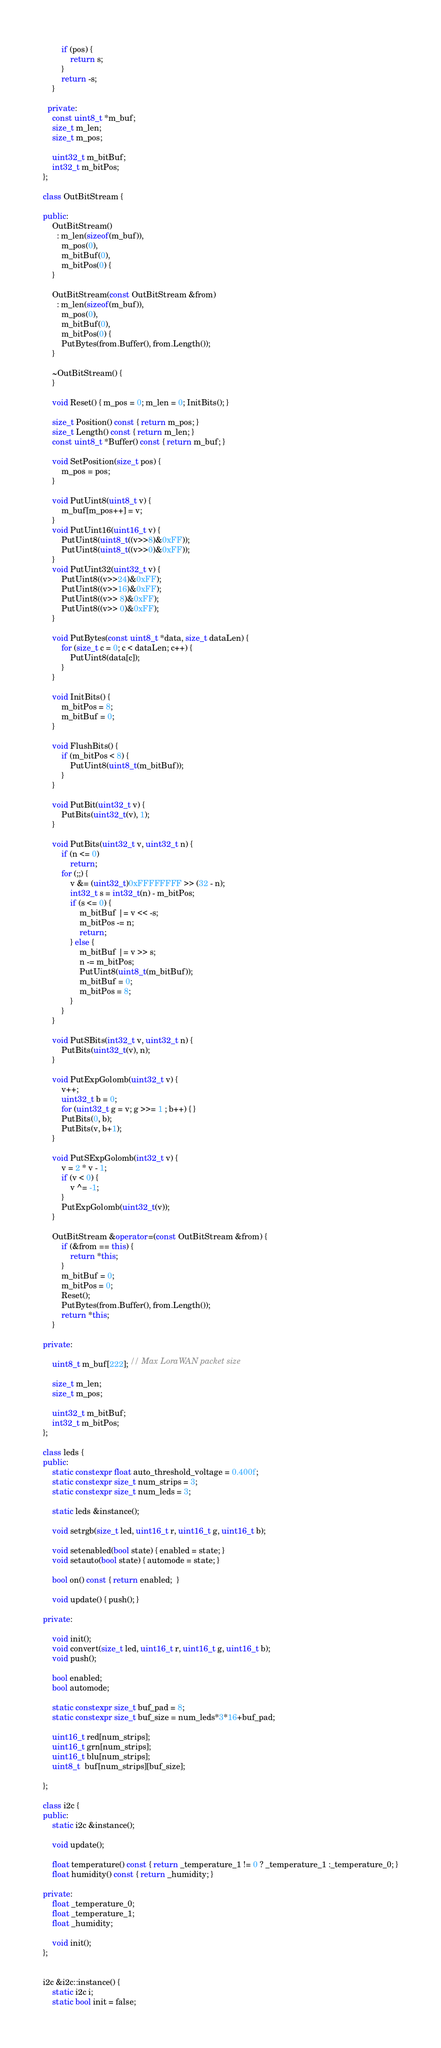<code> <loc_0><loc_0><loc_500><loc_500><_C++_>		if (pos) {
			return s;
		}
		return -s;
	}

  private:
	const uint8_t *m_buf;
	size_t m_len;
	size_t m_pos;

	uint32_t m_bitBuf;
	int32_t m_bitPos;
};

class OutBitStream {

public:
	OutBitStream()
	  : m_len(sizeof(m_buf)),
		m_pos(0),
		m_bitBuf(0),
		m_bitPos(0) {
	}

	OutBitStream(const OutBitStream &from)
	  : m_len(sizeof(m_buf)),
		m_pos(0),
		m_bitBuf(0),
		m_bitPos(0) {
		PutBytes(from.Buffer(), from.Length());
	}

	~OutBitStream() {
	}

	void Reset() { m_pos = 0; m_len = 0; InitBits(); }

	size_t Position() const { return m_pos; }
	size_t Length() const { return m_len; }
	const uint8_t *Buffer() const { return m_buf; }

	void SetPosition(size_t pos) {
		m_pos = pos;
	}

	void PutUint8(uint8_t v) {
		m_buf[m_pos++] = v;
	}
	void PutUint16(uint16_t v) {
		PutUint8(uint8_t((v>>8)&0xFF));
		PutUint8(uint8_t((v>>0)&0xFF));
	}
	void PutUint32(uint32_t v) {
		PutUint8((v>>24)&0xFF);
		PutUint8((v>>16)&0xFF);
		PutUint8((v>> 8)&0xFF);
		PutUint8((v>> 0)&0xFF);
	}

	void PutBytes(const uint8_t *data, size_t dataLen) {
		for (size_t c = 0; c < dataLen; c++) {
			PutUint8(data[c]);
		}
	}

	void InitBits() {
		m_bitPos = 8;
		m_bitBuf = 0;
	}

	void FlushBits() {
		if (m_bitPos < 8) {
			PutUint8(uint8_t(m_bitBuf));
		}
	}

	void PutBit(uint32_t v) {
		PutBits(uint32_t(v), 1);
	}

	void PutBits(uint32_t v, uint32_t n) {
		if (n <= 0)
			return;
		for (;;) {
			v &= (uint32_t)0xFFFFFFFF >> (32 - n);
			int32_t s = int32_t(n) - m_bitPos;
			if (s <= 0) {
				m_bitBuf |= v << -s;
				m_bitPos -= n;
				return;
			} else {
				m_bitBuf |= v >> s;
				n -= m_bitPos;
				PutUint8(uint8_t(m_bitBuf));
				m_bitBuf = 0;
				m_bitPos = 8;
			}
		}
	}

	void PutSBits(int32_t v, uint32_t n) {
		PutBits(uint32_t(v), n);
	}

	void PutExpGolomb(uint32_t v) {
		v++;
		uint32_t b = 0;
		for (uint32_t g = v; g >>= 1 ; b++) { }
		PutBits(0, b);
		PutBits(v, b+1);
	}

	void PutSExpGolomb(int32_t v) {
		v = 2 * v - 1;
		if (v < 0) {
			v ^= -1;
		}
		PutExpGolomb(uint32_t(v));
	}

	OutBitStream &operator=(const OutBitStream &from) {
		if (&from == this) {
			return *this;
		}
		m_bitBuf = 0;
		m_bitPos = 0;
		Reset();
		PutBytes(from.Buffer(), from.Length());
		return *this;
	}

private:

	uint8_t m_buf[222]; // Max LoraWAN packet size

	size_t m_len;
	size_t m_pos;

	uint32_t m_bitBuf;
	int32_t m_bitPos;
};

class leds {
public:
	static constexpr float auto_threshold_voltage = 0.400f;
	static constexpr size_t num_strips = 3;
	static constexpr size_t num_leds = 3;

	static leds &instance();

	void setrgb(size_t led, uint16_t r, uint16_t g, uint16_t b);

	void setenabled(bool state) { enabled = state; }
	void setauto(bool state) { automode = state; }

	bool on() const { return enabled;  }

	void update() { push(); }

private:

	void init();
	void convert(size_t led, uint16_t r, uint16_t g, uint16_t b);
	void push();

	bool enabled;
	bool automode;

	static constexpr size_t buf_pad = 8;
	static constexpr size_t buf_size = num_leds*3*16+buf_pad;

	uint16_t red[num_strips];
	uint16_t grn[num_strips];
	uint16_t blu[num_strips];
	uint8_t  buf[num_strips][buf_size];

};

class i2c {
public:
	static i2c &instance();

	void update();

	float temperature() const { return _temperature_1 != 0 ? _temperature_1 :_temperature_0; }
	float humidity() const { return _humidity; }

private:
	float _temperature_0;
	float _temperature_1;
	float _humidity;

	void init();
};


i2c &i2c::instance() {
	static i2c i;
	static bool init = false;</code> 